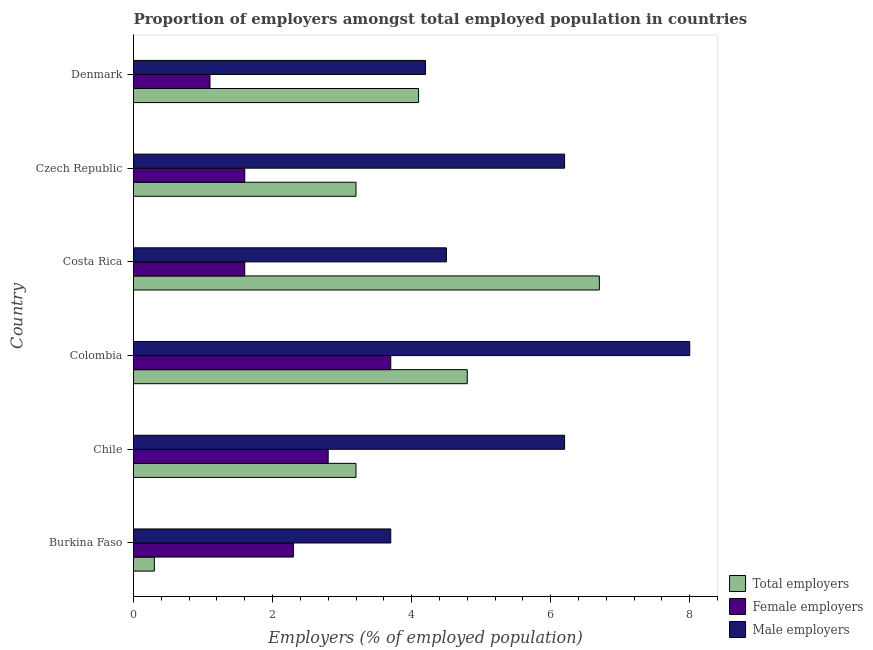How many different coloured bars are there?
Offer a terse response. 3. How many groups of bars are there?
Give a very brief answer. 6. How many bars are there on the 5th tick from the top?
Provide a short and direct response. 3. What is the label of the 5th group of bars from the top?
Offer a very short reply. Chile. In how many cases, is the number of bars for a given country not equal to the number of legend labels?
Keep it short and to the point. 0. What is the percentage of male employers in Chile?
Offer a very short reply. 6.2. Across all countries, what is the maximum percentage of total employers?
Ensure brevity in your answer.  6.7. Across all countries, what is the minimum percentage of male employers?
Keep it short and to the point. 3.7. In which country was the percentage of male employers minimum?
Give a very brief answer. Burkina Faso. What is the total percentage of total employers in the graph?
Provide a succinct answer. 22.3. What is the difference between the percentage of male employers in Czech Republic and the percentage of total employers in Colombia?
Keep it short and to the point. 1.4. What is the average percentage of female employers per country?
Provide a succinct answer. 2.18. What is the ratio of the percentage of female employers in Chile to that in Czech Republic?
Ensure brevity in your answer.  1.75. In how many countries, is the percentage of total employers greater than the average percentage of total employers taken over all countries?
Provide a short and direct response. 3. Is the sum of the percentage of male employers in Colombia and Costa Rica greater than the maximum percentage of total employers across all countries?
Offer a very short reply. Yes. What does the 1st bar from the top in Costa Rica represents?
Your answer should be compact. Male employers. What does the 3rd bar from the bottom in Czech Republic represents?
Provide a succinct answer. Male employers. Is it the case that in every country, the sum of the percentage of total employers and percentage of female employers is greater than the percentage of male employers?
Offer a terse response. No. Are all the bars in the graph horizontal?
Your answer should be very brief. Yes. How many countries are there in the graph?
Make the answer very short. 6. Where does the legend appear in the graph?
Your response must be concise. Bottom right. How many legend labels are there?
Provide a succinct answer. 3. What is the title of the graph?
Provide a short and direct response. Proportion of employers amongst total employed population in countries. What is the label or title of the X-axis?
Your response must be concise. Employers (% of employed population). What is the Employers (% of employed population) in Total employers in Burkina Faso?
Offer a terse response. 0.3. What is the Employers (% of employed population) of Female employers in Burkina Faso?
Give a very brief answer. 2.3. What is the Employers (% of employed population) in Male employers in Burkina Faso?
Provide a succinct answer. 3.7. What is the Employers (% of employed population) in Total employers in Chile?
Make the answer very short. 3.2. What is the Employers (% of employed population) of Female employers in Chile?
Provide a succinct answer. 2.8. What is the Employers (% of employed population) in Male employers in Chile?
Ensure brevity in your answer.  6.2. What is the Employers (% of employed population) of Total employers in Colombia?
Give a very brief answer. 4.8. What is the Employers (% of employed population) in Female employers in Colombia?
Your response must be concise. 3.7. What is the Employers (% of employed population) in Total employers in Costa Rica?
Offer a very short reply. 6.7. What is the Employers (% of employed population) in Female employers in Costa Rica?
Give a very brief answer. 1.6. What is the Employers (% of employed population) in Male employers in Costa Rica?
Your answer should be very brief. 4.5. What is the Employers (% of employed population) of Total employers in Czech Republic?
Provide a succinct answer. 3.2. What is the Employers (% of employed population) in Female employers in Czech Republic?
Keep it short and to the point. 1.6. What is the Employers (% of employed population) of Male employers in Czech Republic?
Make the answer very short. 6.2. What is the Employers (% of employed population) in Total employers in Denmark?
Your answer should be very brief. 4.1. What is the Employers (% of employed population) of Female employers in Denmark?
Keep it short and to the point. 1.1. What is the Employers (% of employed population) in Male employers in Denmark?
Your answer should be compact. 4.2. Across all countries, what is the maximum Employers (% of employed population) of Total employers?
Give a very brief answer. 6.7. Across all countries, what is the maximum Employers (% of employed population) of Female employers?
Make the answer very short. 3.7. Across all countries, what is the minimum Employers (% of employed population) of Total employers?
Ensure brevity in your answer.  0.3. Across all countries, what is the minimum Employers (% of employed population) in Female employers?
Your response must be concise. 1.1. Across all countries, what is the minimum Employers (% of employed population) of Male employers?
Your response must be concise. 3.7. What is the total Employers (% of employed population) of Total employers in the graph?
Your answer should be compact. 22.3. What is the total Employers (% of employed population) of Female employers in the graph?
Your answer should be very brief. 13.1. What is the total Employers (% of employed population) of Male employers in the graph?
Provide a short and direct response. 32.8. What is the difference between the Employers (% of employed population) of Total employers in Burkina Faso and that in Chile?
Your response must be concise. -2.9. What is the difference between the Employers (% of employed population) in Female employers in Burkina Faso and that in Colombia?
Ensure brevity in your answer.  -1.4. What is the difference between the Employers (% of employed population) in Female employers in Burkina Faso and that in Costa Rica?
Your response must be concise. 0.7. What is the difference between the Employers (% of employed population) in Male employers in Burkina Faso and that in Costa Rica?
Provide a short and direct response. -0.8. What is the difference between the Employers (% of employed population) of Total employers in Burkina Faso and that in Czech Republic?
Ensure brevity in your answer.  -2.9. What is the difference between the Employers (% of employed population) of Female employers in Burkina Faso and that in Czech Republic?
Offer a very short reply. 0.7. What is the difference between the Employers (% of employed population) in Total employers in Burkina Faso and that in Denmark?
Your answer should be very brief. -3.8. What is the difference between the Employers (% of employed population) in Male employers in Burkina Faso and that in Denmark?
Keep it short and to the point. -0.5. What is the difference between the Employers (% of employed population) in Total employers in Chile and that in Colombia?
Your answer should be very brief. -1.6. What is the difference between the Employers (% of employed population) in Male employers in Chile and that in Colombia?
Make the answer very short. -1.8. What is the difference between the Employers (% of employed population) of Total employers in Chile and that in Costa Rica?
Keep it short and to the point. -3.5. What is the difference between the Employers (% of employed population) in Female employers in Chile and that in Czech Republic?
Make the answer very short. 1.2. What is the difference between the Employers (% of employed population) of Male employers in Chile and that in Czech Republic?
Give a very brief answer. 0. What is the difference between the Employers (% of employed population) of Female employers in Chile and that in Denmark?
Give a very brief answer. 1.7. What is the difference between the Employers (% of employed population) of Total employers in Colombia and that in Costa Rica?
Provide a short and direct response. -1.9. What is the difference between the Employers (% of employed population) of Female employers in Colombia and that in Costa Rica?
Your answer should be very brief. 2.1. What is the difference between the Employers (% of employed population) in Male employers in Colombia and that in Costa Rica?
Your answer should be very brief. 3.5. What is the difference between the Employers (% of employed population) in Male employers in Colombia and that in Denmark?
Make the answer very short. 3.8. What is the difference between the Employers (% of employed population) of Total employers in Costa Rica and that in Czech Republic?
Offer a very short reply. 3.5. What is the difference between the Employers (% of employed population) of Female employers in Costa Rica and that in Czech Republic?
Ensure brevity in your answer.  0. What is the difference between the Employers (% of employed population) in Total employers in Costa Rica and that in Denmark?
Your response must be concise. 2.6. What is the difference between the Employers (% of employed population) of Male employers in Costa Rica and that in Denmark?
Your answer should be compact. 0.3. What is the difference between the Employers (% of employed population) in Female employers in Czech Republic and that in Denmark?
Give a very brief answer. 0.5. What is the difference between the Employers (% of employed population) in Total employers in Burkina Faso and the Employers (% of employed population) in Male employers in Chile?
Offer a terse response. -5.9. What is the difference between the Employers (% of employed population) of Female employers in Burkina Faso and the Employers (% of employed population) of Male employers in Chile?
Make the answer very short. -3.9. What is the difference between the Employers (% of employed population) of Female employers in Burkina Faso and the Employers (% of employed population) of Male employers in Colombia?
Your response must be concise. -5.7. What is the difference between the Employers (% of employed population) in Total employers in Burkina Faso and the Employers (% of employed population) in Male employers in Costa Rica?
Make the answer very short. -4.2. What is the difference between the Employers (% of employed population) of Total employers in Burkina Faso and the Employers (% of employed population) of Female employers in Czech Republic?
Your response must be concise. -1.3. What is the difference between the Employers (% of employed population) of Female employers in Chile and the Employers (% of employed population) of Male employers in Colombia?
Give a very brief answer. -5.2. What is the difference between the Employers (% of employed population) of Total employers in Chile and the Employers (% of employed population) of Female employers in Costa Rica?
Keep it short and to the point. 1.6. What is the difference between the Employers (% of employed population) in Female employers in Chile and the Employers (% of employed population) in Male employers in Costa Rica?
Your answer should be very brief. -1.7. What is the difference between the Employers (% of employed population) of Total employers in Chile and the Employers (% of employed population) of Female employers in Czech Republic?
Your response must be concise. 1.6. What is the difference between the Employers (% of employed population) of Female employers in Chile and the Employers (% of employed population) of Male employers in Czech Republic?
Your answer should be compact. -3.4. What is the difference between the Employers (% of employed population) of Total employers in Chile and the Employers (% of employed population) of Female employers in Denmark?
Ensure brevity in your answer.  2.1. What is the difference between the Employers (% of employed population) in Female employers in Chile and the Employers (% of employed population) in Male employers in Denmark?
Offer a terse response. -1.4. What is the difference between the Employers (% of employed population) of Total employers in Colombia and the Employers (% of employed population) of Female employers in Costa Rica?
Your answer should be very brief. 3.2. What is the difference between the Employers (% of employed population) in Female employers in Colombia and the Employers (% of employed population) in Male employers in Costa Rica?
Your response must be concise. -0.8. What is the difference between the Employers (% of employed population) in Total employers in Colombia and the Employers (% of employed population) in Male employers in Czech Republic?
Give a very brief answer. -1.4. What is the difference between the Employers (% of employed population) in Female employers in Colombia and the Employers (% of employed population) in Male employers in Czech Republic?
Keep it short and to the point. -2.5. What is the difference between the Employers (% of employed population) in Total employers in Colombia and the Employers (% of employed population) in Male employers in Denmark?
Your response must be concise. 0.6. What is the difference between the Employers (% of employed population) of Female employers in Colombia and the Employers (% of employed population) of Male employers in Denmark?
Your answer should be compact. -0.5. What is the difference between the Employers (% of employed population) in Total employers in Costa Rica and the Employers (% of employed population) in Female employers in Czech Republic?
Your response must be concise. 5.1. What is the difference between the Employers (% of employed population) of Total employers in Costa Rica and the Employers (% of employed population) of Male employers in Czech Republic?
Make the answer very short. 0.5. What is the difference between the Employers (% of employed population) in Total employers in Costa Rica and the Employers (% of employed population) in Female employers in Denmark?
Offer a terse response. 5.6. What is the difference between the Employers (% of employed population) in Total employers in Costa Rica and the Employers (% of employed population) in Male employers in Denmark?
Offer a terse response. 2.5. What is the difference between the Employers (% of employed population) in Female employers in Costa Rica and the Employers (% of employed population) in Male employers in Denmark?
Your answer should be compact. -2.6. What is the difference between the Employers (% of employed population) of Total employers in Czech Republic and the Employers (% of employed population) of Female employers in Denmark?
Ensure brevity in your answer.  2.1. What is the difference between the Employers (% of employed population) of Total employers in Czech Republic and the Employers (% of employed population) of Male employers in Denmark?
Your answer should be compact. -1. What is the difference between the Employers (% of employed population) in Female employers in Czech Republic and the Employers (% of employed population) in Male employers in Denmark?
Provide a succinct answer. -2.6. What is the average Employers (% of employed population) of Total employers per country?
Make the answer very short. 3.72. What is the average Employers (% of employed population) in Female employers per country?
Offer a terse response. 2.18. What is the average Employers (% of employed population) of Male employers per country?
Offer a terse response. 5.47. What is the difference between the Employers (% of employed population) of Total employers and Employers (% of employed population) of Female employers in Burkina Faso?
Make the answer very short. -2. What is the difference between the Employers (% of employed population) of Female employers and Employers (% of employed population) of Male employers in Burkina Faso?
Make the answer very short. -1.4. What is the difference between the Employers (% of employed population) in Total employers and Employers (% of employed population) in Male employers in Chile?
Your answer should be very brief. -3. What is the difference between the Employers (% of employed population) in Total employers and Employers (% of employed population) in Male employers in Colombia?
Keep it short and to the point. -3.2. What is the difference between the Employers (% of employed population) in Female employers and Employers (% of employed population) in Male employers in Colombia?
Offer a terse response. -4.3. What is the difference between the Employers (% of employed population) of Total employers and Employers (% of employed population) of Male employers in Czech Republic?
Keep it short and to the point. -3. What is the difference between the Employers (% of employed population) of Female employers and Employers (% of employed population) of Male employers in Czech Republic?
Make the answer very short. -4.6. What is the difference between the Employers (% of employed population) in Female employers and Employers (% of employed population) in Male employers in Denmark?
Keep it short and to the point. -3.1. What is the ratio of the Employers (% of employed population) of Total employers in Burkina Faso to that in Chile?
Your answer should be very brief. 0.09. What is the ratio of the Employers (% of employed population) of Female employers in Burkina Faso to that in Chile?
Your response must be concise. 0.82. What is the ratio of the Employers (% of employed population) of Male employers in Burkina Faso to that in Chile?
Keep it short and to the point. 0.6. What is the ratio of the Employers (% of employed population) in Total employers in Burkina Faso to that in Colombia?
Provide a succinct answer. 0.06. What is the ratio of the Employers (% of employed population) in Female employers in Burkina Faso to that in Colombia?
Give a very brief answer. 0.62. What is the ratio of the Employers (% of employed population) of Male employers in Burkina Faso to that in Colombia?
Keep it short and to the point. 0.46. What is the ratio of the Employers (% of employed population) in Total employers in Burkina Faso to that in Costa Rica?
Offer a very short reply. 0.04. What is the ratio of the Employers (% of employed population) in Female employers in Burkina Faso to that in Costa Rica?
Your answer should be very brief. 1.44. What is the ratio of the Employers (% of employed population) of Male employers in Burkina Faso to that in Costa Rica?
Make the answer very short. 0.82. What is the ratio of the Employers (% of employed population) of Total employers in Burkina Faso to that in Czech Republic?
Offer a terse response. 0.09. What is the ratio of the Employers (% of employed population) in Female employers in Burkina Faso to that in Czech Republic?
Make the answer very short. 1.44. What is the ratio of the Employers (% of employed population) of Male employers in Burkina Faso to that in Czech Republic?
Provide a succinct answer. 0.6. What is the ratio of the Employers (% of employed population) in Total employers in Burkina Faso to that in Denmark?
Your answer should be compact. 0.07. What is the ratio of the Employers (% of employed population) in Female employers in Burkina Faso to that in Denmark?
Keep it short and to the point. 2.09. What is the ratio of the Employers (% of employed population) in Male employers in Burkina Faso to that in Denmark?
Ensure brevity in your answer.  0.88. What is the ratio of the Employers (% of employed population) in Total employers in Chile to that in Colombia?
Your response must be concise. 0.67. What is the ratio of the Employers (% of employed population) in Female employers in Chile to that in Colombia?
Keep it short and to the point. 0.76. What is the ratio of the Employers (% of employed population) in Male employers in Chile to that in Colombia?
Your answer should be compact. 0.78. What is the ratio of the Employers (% of employed population) of Total employers in Chile to that in Costa Rica?
Your answer should be very brief. 0.48. What is the ratio of the Employers (% of employed population) of Female employers in Chile to that in Costa Rica?
Ensure brevity in your answer.  1.75. What is the ratio of the Employers (% of employed population) of Male employers in Chile to that in Costa Rica?
Give a very brief answer. 1.38. What is the ratio of the Employers (% of employed population) of Male employers in Chile to that in Czech Republic?
Your response must be concise. 1. What is the ratio of the Employers (% of employed population) in Total employers in Chile to that in Denmark?
Provide a succinct answer. 0.78. What is the ratio of the Employers (% of employed population) in Female employers in Chile to that in Denmark?
Provide a succinct answer. 2.55. What is the ratio of the Employers (% of employed population) of Male employers in Chile to that in Denmark?
Provide a short and direct response. 1.48. What is the ratio of the Employers (% of employed population) of Total employers in Colombia to that in Costa Rica?
Offer a very short reply. 0.72. What is the ratio of the Employers (% of employed population) in Female employers in Colombia to that in Costa Rica?
Your answer should be compact. 2.31. What is the ratio of the Employers (% of employed population) of Male employers in Colombia to that in Costa Rica?
Make the answer very short. 1.78. What is the ratio of the Employers (% of employed population) of Female employers in Colombia to that in Czech Republic?
Provide a short and direct response. 2.31. What is the ratio of the Employers (% of employed population) in Male employers in Colombia to that in Czech Republic?
Keep it short and to the point. 1.29. What is the ratio of the Employers (% of employed population) in Total employers in Colombia to that in Denmark?
Provide a short and direct response. 1.17. What is the ratio of the Employers (% of employed population) of Female employers in Colombia to that in Denmark?
Keep it short and to the point. 3.36. What is the ratio of the Employers (% of employed population) of Male employers in Colombia to that in Denmark?
Provide a short and direct response. 1.9. What is the ratio of the Employers (% of employed population) of Total employers in Costa Rica to that in Czech Republic?
Your answer should be compact. 2.09. What is the ratio of the Employers (% of employed population) in Female employers in Costa Rica to that in Czech Republic?
Offer a terse response. 1. What is the ratio of the Employers (% of employed population) in Male employers in Costa Rica to that in Czech Republic?
Give a very brief answer. 0.73. What is the ratio of the Employers (% of employed population) of Total employers in Costa Rica to that in Denmark?
Your response must be concise. 1.63. What is the ratio of the Employers (% of employed population) in Female employers in Costa Rica to that in Denmark?
Your answer should be very brief. 1.45. What is the ratio of the Employers (% of employed population) of Male employers in Costa Rica to that in Denmark?
Ensure brevity in your answer.  1.07. What is the ratio of the Employers (% of employed population) of Total employers in Czech Republic to that in Denmark?
Ensure brevity in your answer.  0.78. What is the ratio of the Employers (% of employed population) of Female employers in Czech Republic to that in Denmark?
Provide a succinct answer. 1.45. What is the ratio of the Employers (% of employed population) in Male employers in Czech Republic to that in Denmark?
Make the answer very short. 1.48. What is the difference between the highest and the second highest Employers (% of employed population) of Total employers?
Your answer should be very brief. 1.9. What is the difference between the highest and the second highest Employers (% of employed population) of Female employers?
Your answer should be compact. 0.9. 